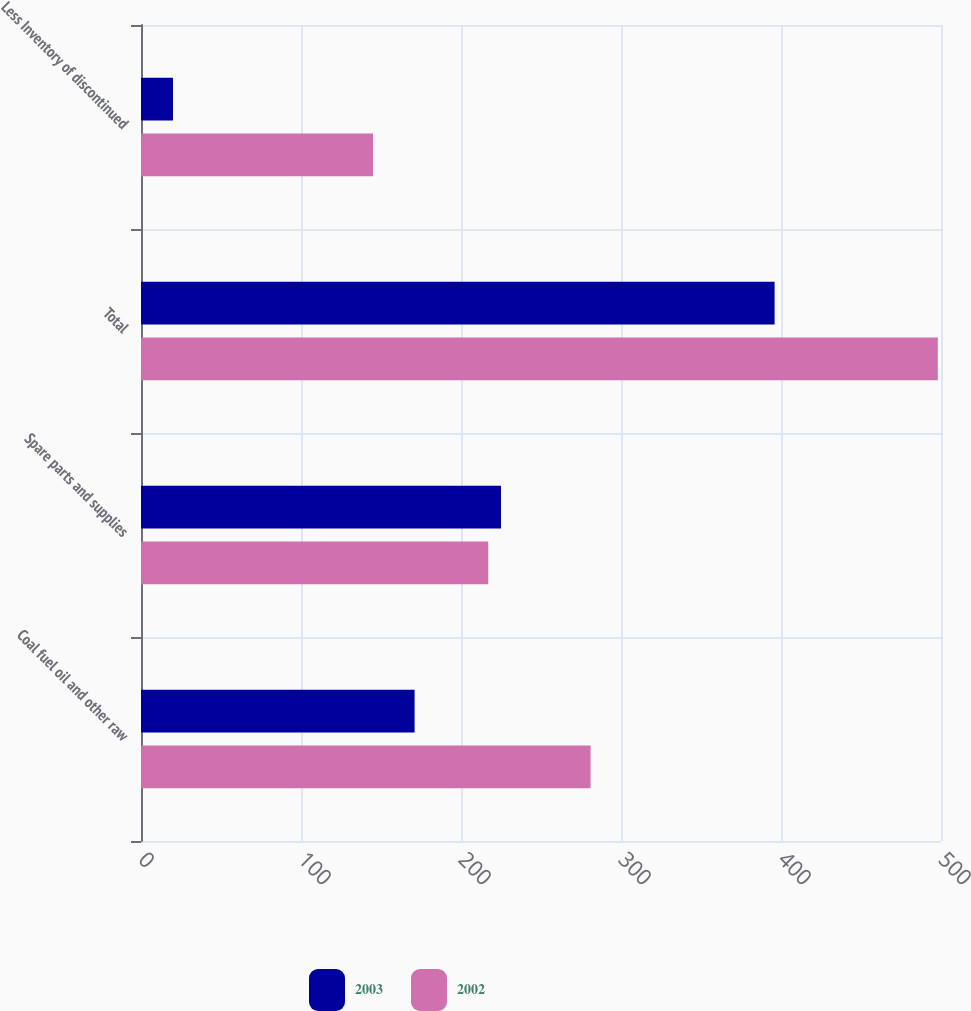<chart> <loc_0><loc_0><loc_500><loc_500><stacked_bar_chart><ecel><fcel>Coal fuel oil and other raw<fcel>Spare parts and supplies<fcel>Total<fcel>Less Inventory of discontinued<nl><fcel>2003<fcel>171<fcel>225<fcel>396<fcel>20<nl><fcel>2002<fcel>281<fcel>217<fcel>498<fcel>145<nl></chart> 